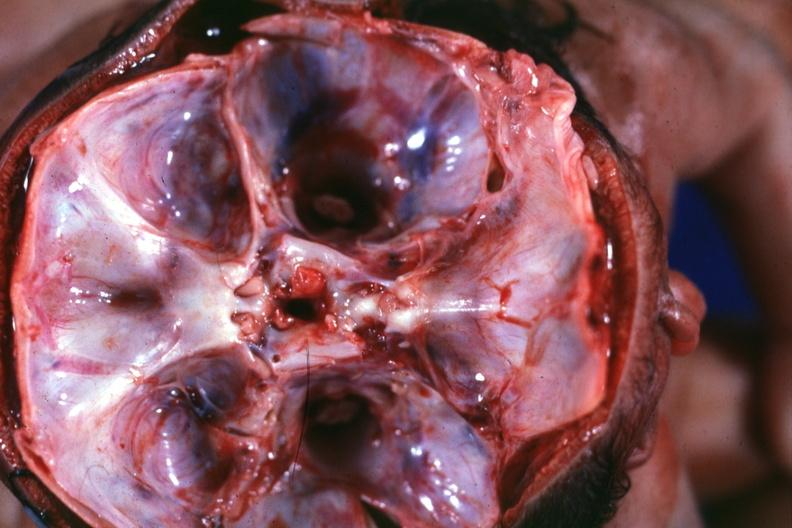what is present?
Answer the question using a single word or phrase. Cephalothoracopagus janiceps 